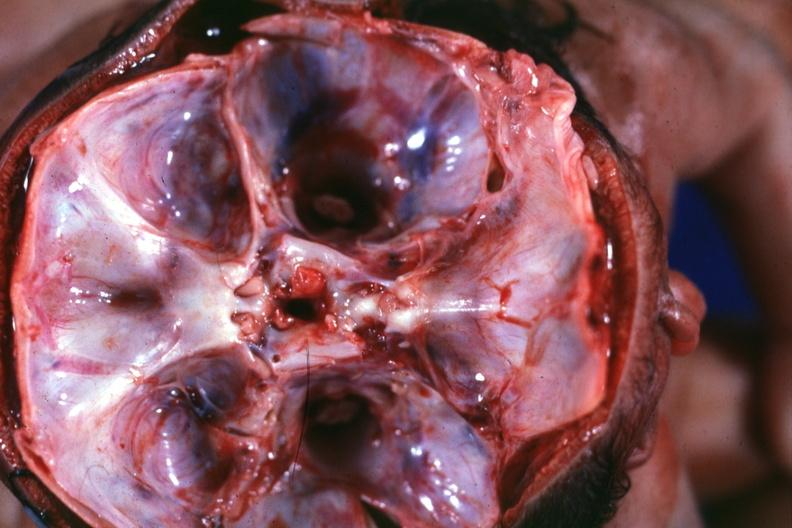what is present?
Answer the question using a single word or phrase. Cephalothoracopagus janiceps 